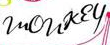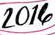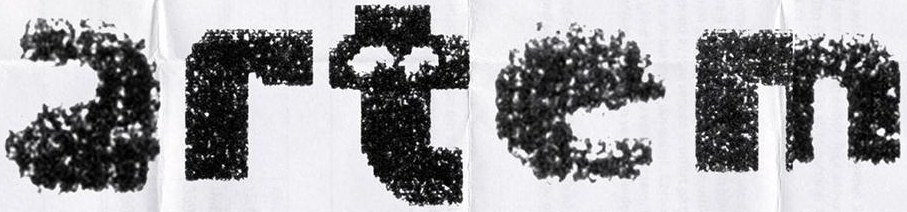Transcribe the words shown in these images in order, separated by a semicolon. monkey; 2014; artem 